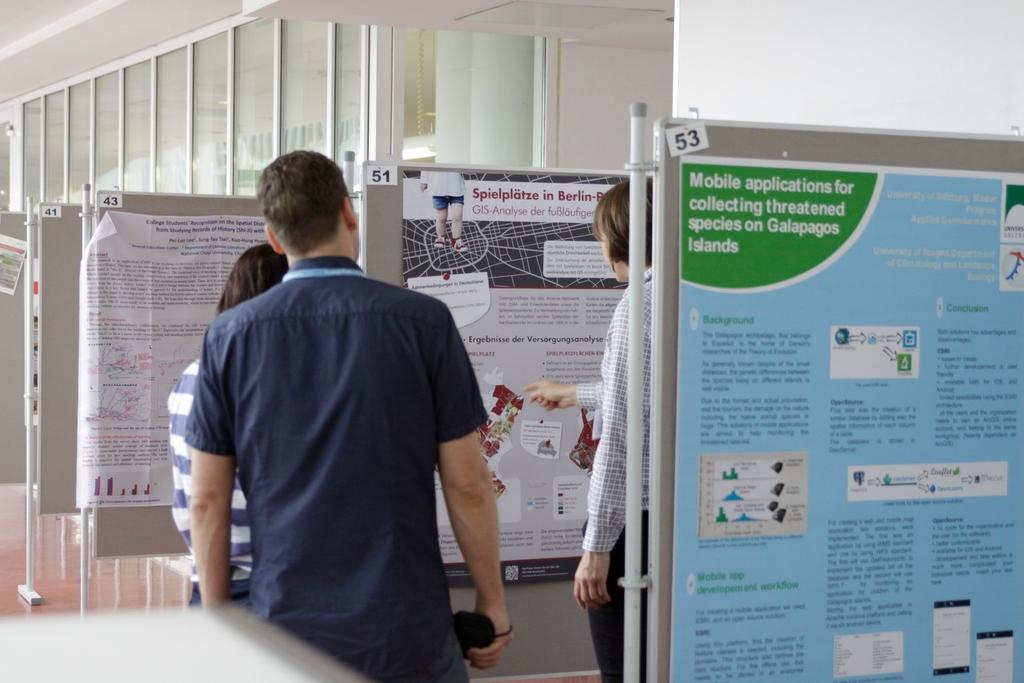How many people are present in the image? There are three persons standing in the image. What can be seen on the boards in the image? There are boards with posters in the image. What is visible in the background of the image? There are windows and a wall in the background of the image. What type of tray is being held by the servant in the image? There is no servant or tray present in the image. 